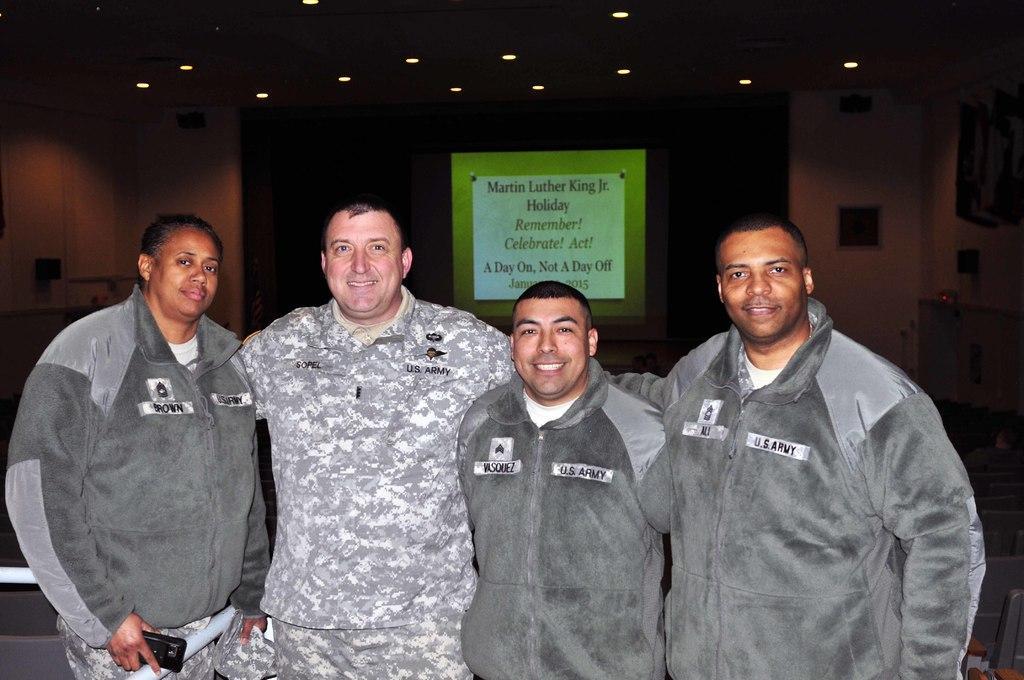Please provide a concise description of this image. There are four people standing. Person on the left is holding a mobile. In the back there is a poster. On the ceiling there are lights. 